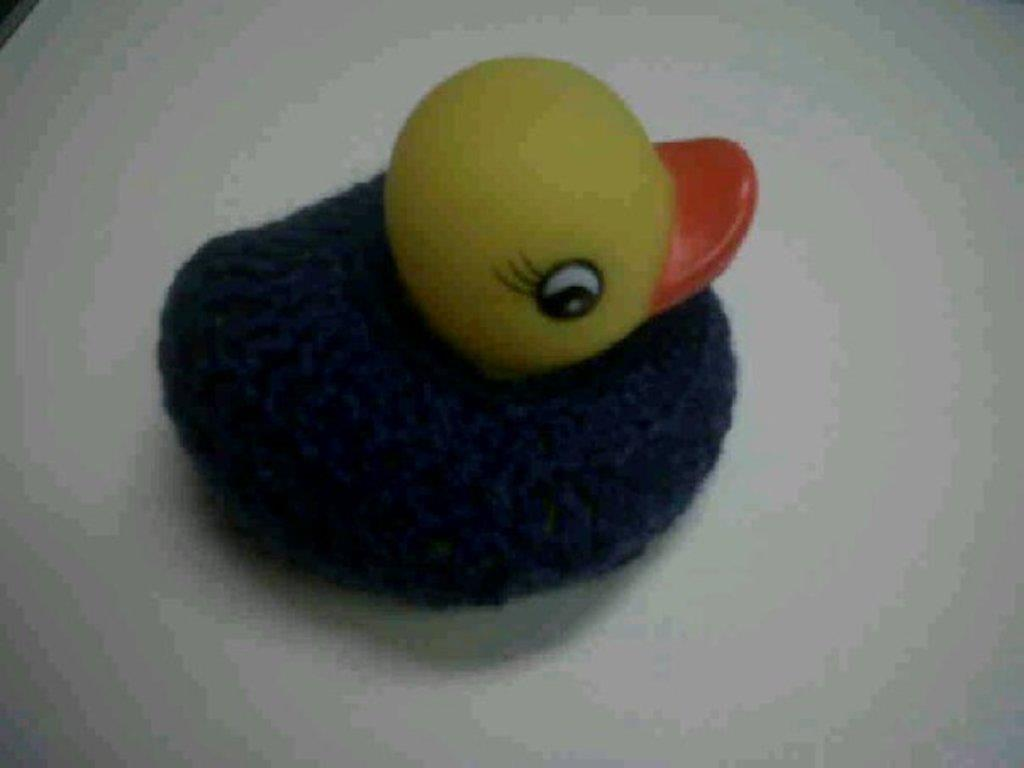What object can be seen in the image? There is a toy in the image. Where is the toy located? The toy is on a surface. What color is the background of the image? The background of the image is white. What health advice can be seen on the toy in the image? There is no health advice present on the toy in the image. Is there a girl interacting with the toy in the image? There is no girl present in the image. 